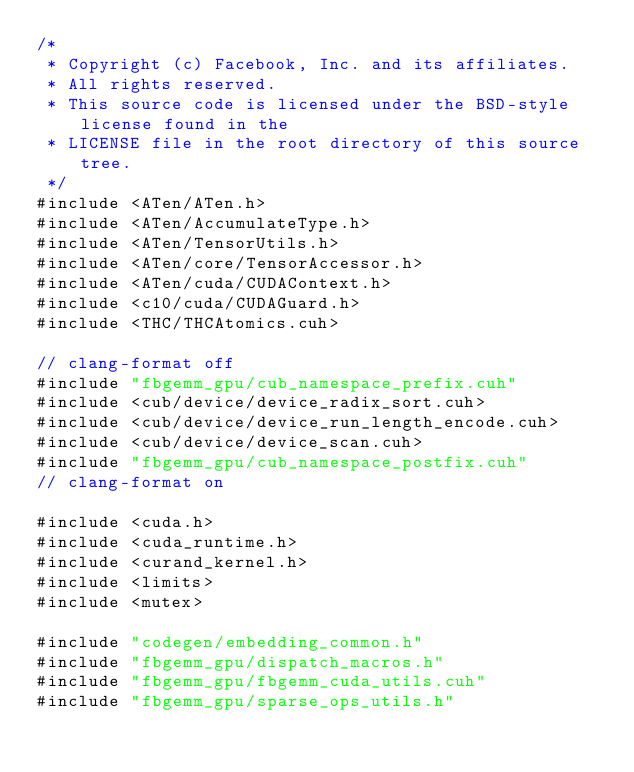Convert code to text. <code><loc_0><loc_0><loc_500><loc_500><_Cuda_>/*
 * Copyright (c) Facebook, Inc. and its affiliates.
 * All rights reserved.
 * This source code is licensed under the BSD-style license found in the
 * LICENSE file in the root directory of this source tree.
 */
#include <ATen/ATen.h>
#include <ATen/AccumulateType.h>
#include <ATen/TensorUtils.h>
#include <ATen/core/TensorAccessor.h>
#include <ATen/cuda/CUDAContext.h>
#include <c10/cuda/CUDAGuard.h>
#include <THC/THCAtomics.cuh>

// clang-format off
#include "fbgemm_gpu/cub_namespace_prefix.cuh"
#include <cub/device/device_radix_sort.cuh>
#include <cub/device/device_run_length_encode.cuh>
#include <cub/device/device_scan.cuh>
#include "fbgemm_gpu/cub_namespace_postfix.cuh"
// clang-format on

#include <cuda.h>
#include <cuda_runtime.h>
#include <curand_kernel.h>
#include <limits>
#include <mutex>

#include "codegen/embedding_common.h"
#include "fbgemm_gpu/dispatch_macros.h"
#include "fbgemm_gpu/fbgemm_cuda_utils.cuh"
#include "fbgemm_gpu/sparse_ops_utils.h"
</code> 